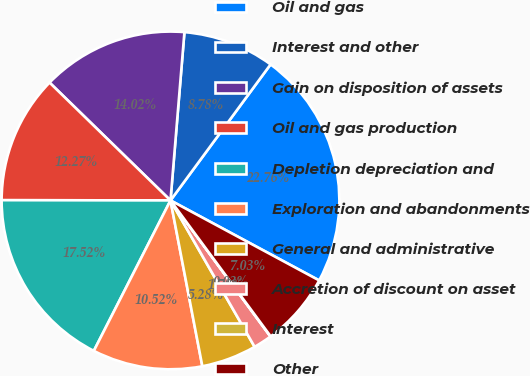Convert chart to OTSL. <chart><loc_0><loc_0><loc_500><loc_500><pie_chart><fcel>Oil and gas<fcel>Interest and other<fcel>Gain on disposition of assets<fcel>Oil and gas production<fcel>Depletion depreciation and<fcel>Exploration and abandonments<fcel>General and administrative<fcel>Accretion of discount on asset<fcel>Interest<fcel>Other<nl><fcel>22.76%<fcel>8.78%<fcel>14.02%<fcel>12.27%<fcel>17.52%<fcel>10.52%<fcel>5.28%<fcel>1.78%<fcel>0.03%<fcel>7.03%<nl></chart> 